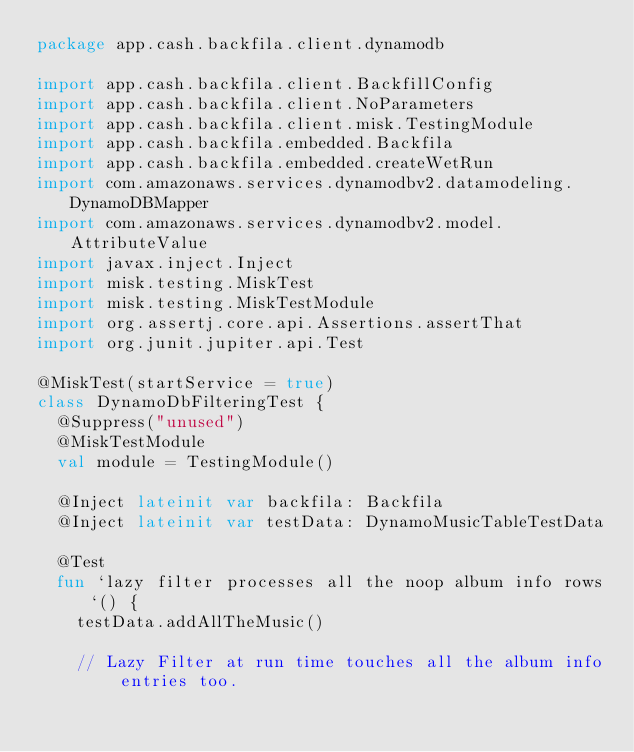Convert code to text. <code><loc_0><loc_0><loc_500><loc_500><_Kotlin_>package app.cash.backfila.client.dynamodb

import app.cash.backfila.client.BackfillConfig
import app.cash.backfila.client.NoParameters
import app.cash.backfila.client.misk.TestingModule
import app.cash.backfila.embedded.Backfila
import app.cash.backfila.embedded.createWetRun
import com.amazonaws.services.dynamodbv2.datamodeling.DynamoDBMapper
import com.amazonaws.services.dynamodbv2.model.AttributeValue
import javax.inject.Inject
import misk.testing.MiskTest
import misk.testing.MiskTestModule
import org.assertj.core.api.Assertions.assertThat
import org.junit.jupiter.api.Test

@MiskTest(startService = true)
class DynamoDbFilteringTest {
  @Suppress("unused")
  @MiskTestModule
  val module = TestingModule()

  @Inject lateinit var backfila: Backfila
  @Inject lateinit var testData: DynamoMusicTableTestData

  @Test
  fun `lazy filter processes all the noop album info rows`() {
    testData.addAllTheMusic()

    // Lazy Filter at run time touches all the album info entries too.</code> 